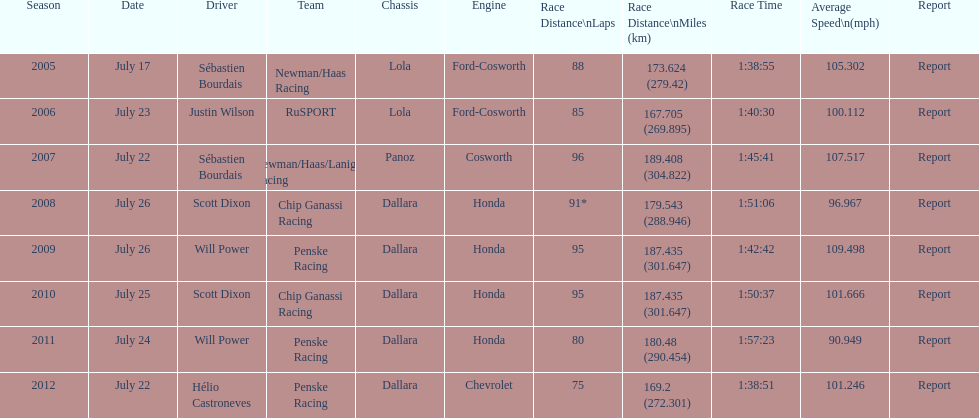In the table, what is the total number of dallara chassis displayed? 5. 